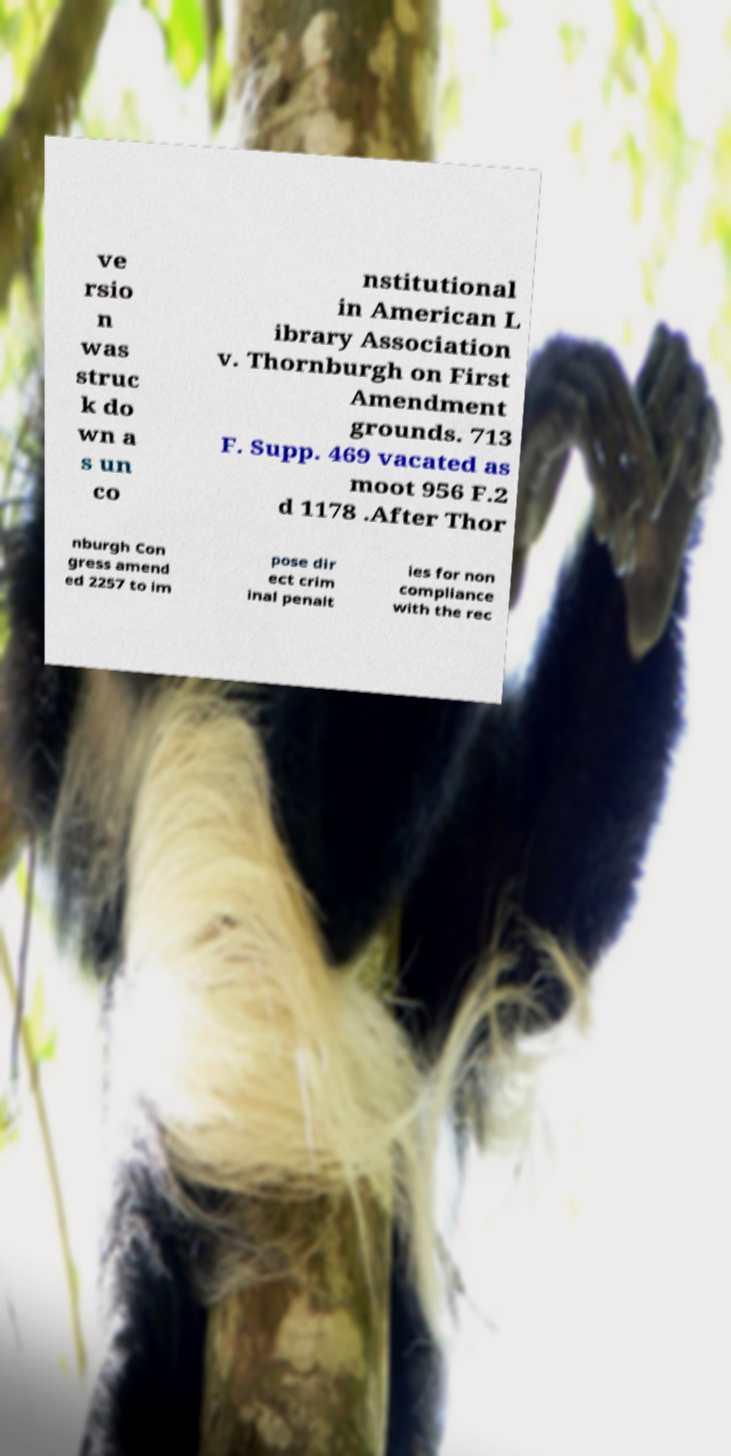Can you read and provide the text displayed in the image?This photo seems to have some interesting text. Can you extract and type it out for me? ve rsio n was struc k do wn a s un co nstitutional in American L ibrary Association v. Thornburgh on First Amendment grounds. 713 F. Supp. 469 vacated as moot 956 F.2 d 1178 .After Thor nburgh Con gress amend ed 2257 to im pose dir ect crim inal penalt ies for non compliance with the rec 